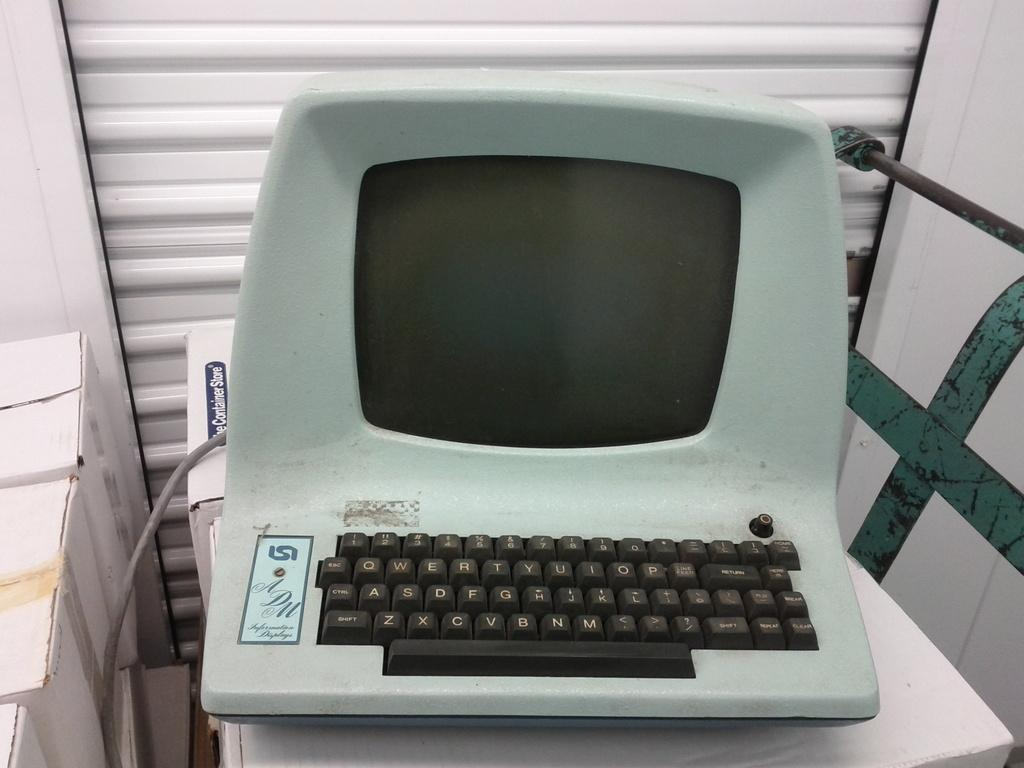Provide a one-sentence caption for the provided image. A late model computer terminal is labeled with the initials ADM. 